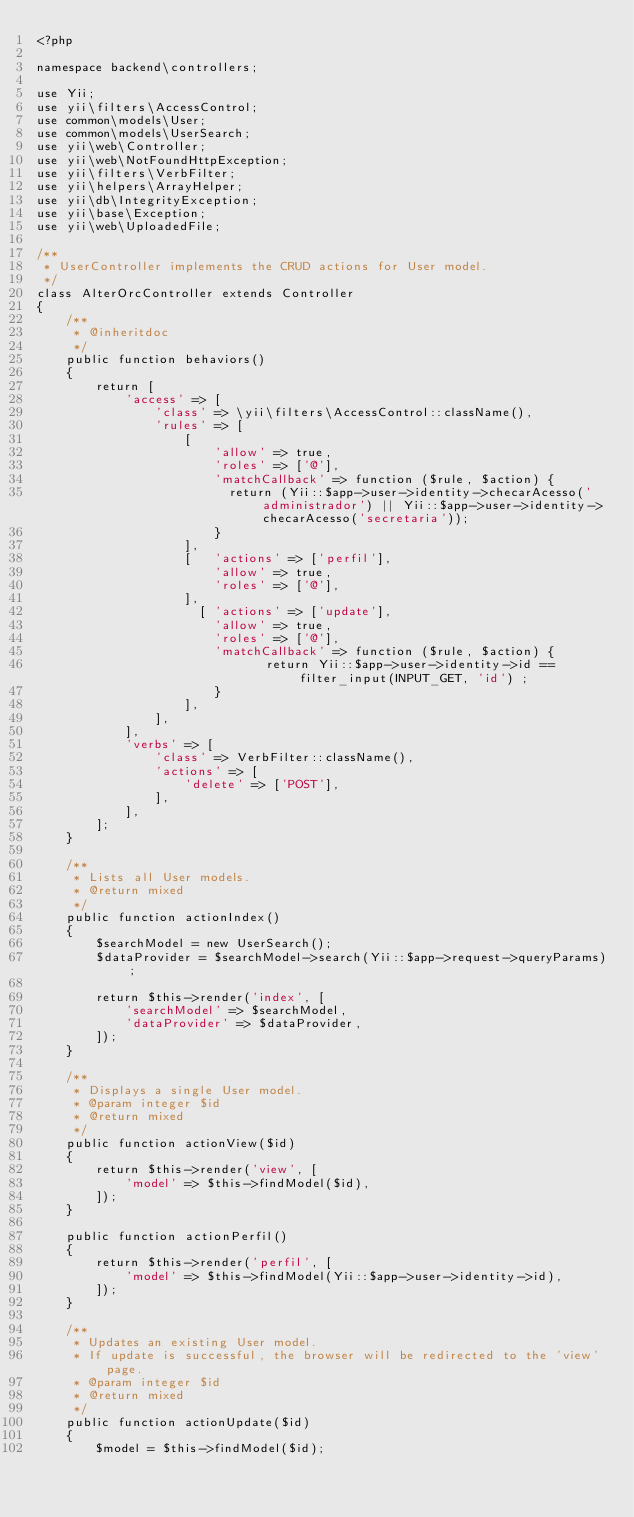<code> <loc_0><loc_0><loc_500><loc_500><_PHP_><?php

namespace backend\controllers;

use Yii;
use yii\filters\AccessControl;
use common\models\User;
use common\models\UserSearch;
use yii\web\Controller;
use yii\web\NotFoundHttpException;
use yii\filters\VerbFilter;
use yii\helpers\ArrayHelper;
use yii\db\IntegrityException;
use yii\base\Exception;
use yii\web\UploadedFile;

/**
 * UserController implements the CRUD actions for User model.
 */
class AlterOrcController extends Controller
{
    /**
     * @inheritdoc
     */
    public function behaviors()
    {
        return [
            'access' => [
                'class' => \yii\filters\AccessControl::className(),
                'rules' => [
                    [
                        'allow' => true,
                        'roles' => ['@'],
                        'matchCallback' => function ($rule, $action) {
                          return (Yii::$app->user->identity->checarAcesso('administrador') || Yii::$app->user->identity->checarAcesso('secretaria'));
                        }
                    ],
                    [   'actions' => ['perfil'],
                        'allow' => true,
                        'roles' => ['@'],
                    ],
                      [ 'actions' => ['update'],
                        'allow' => true,
                        'roles' => ['@'],
                        'matchCallback' => function ($rule, $action) {
                               return Yii::$app->user->identity->id == filter_input(INPUT_GET, 'id') ;
                        }
                    ],
                ],
            ],
            'verbs' => [
                'class' => VerbFilter::className(),
                'actions' => [
                    'delete' => ['POST'],
                ],
            ],
        ];
    }

    /**
     * Lists all User models.
     * @return mixed
     */
    public function actionIndex()
    {
        $searchModel = new UserSearch();
        $dataProvider = $searchModel->search(Yii::$app->request->queryParams);

        return $this->render('index', [
            'searchModel' => $searchModel,
            'dataProvider' => $dataProvider,
        ]);
    }

    /**
     * Displays a single User model.
     * @param integer $id
     * @return mixed
     */
    public function actionView($id)
    {
        return $this->render('view', [
            'model' => $this->findModel($id),
        ]);
    }

    public function actionPerfil()
    {
        return $this->render('perfil', [
            'model' => $this->findModel(Yii::$app->user->identity->id),
        ]);
    }

    /**
     * Updates an existing User model.
     * If update is successful, the browser will be redirected to the 'view' page.
     * @param integer $id
     * @return mixed
     */
    public function actionUpdate($id)
    {
        $model = $this->findModel($id);
</code> 